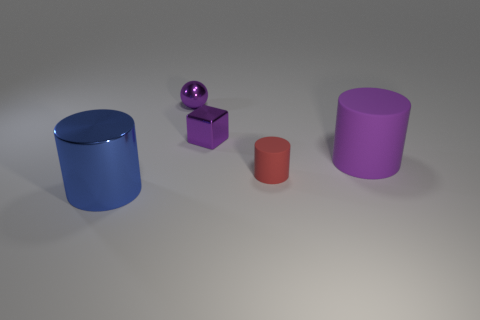Are there any matte cylinders that have the same color as the ball?
Offer a very short reply. Yes. The rubber cylinder that is the same size as the sphere is what color?
Your response must be concise. Red. There is a big rubber thing; is its color the same as the shiny thing right of the metal ball?
Your response must be concise. Yes. The tiny sphere is what color?
Make the answer very short. Purple. There is a large thing that is behind the large blue cylinder; what material is it?
Your answer should be compact. Rubber. What is the size of the blue metal object that is the same shape as the small rubber thing?
Keep it short and to the point. Large. Are there fewer large blue metal objects behind the large metallic cylinder than things?
Your response must be concise. Yes. Are there any things?
Make the answer very short. Yes. There is a big metal thing that is the same shape as the tiny red thing; what color is it?
Provide a succinct answer. Blue. Does the matte cylinder that is behind the small cylinder have the same color as the metallic cylinder?
Your answer should be compact. No. 